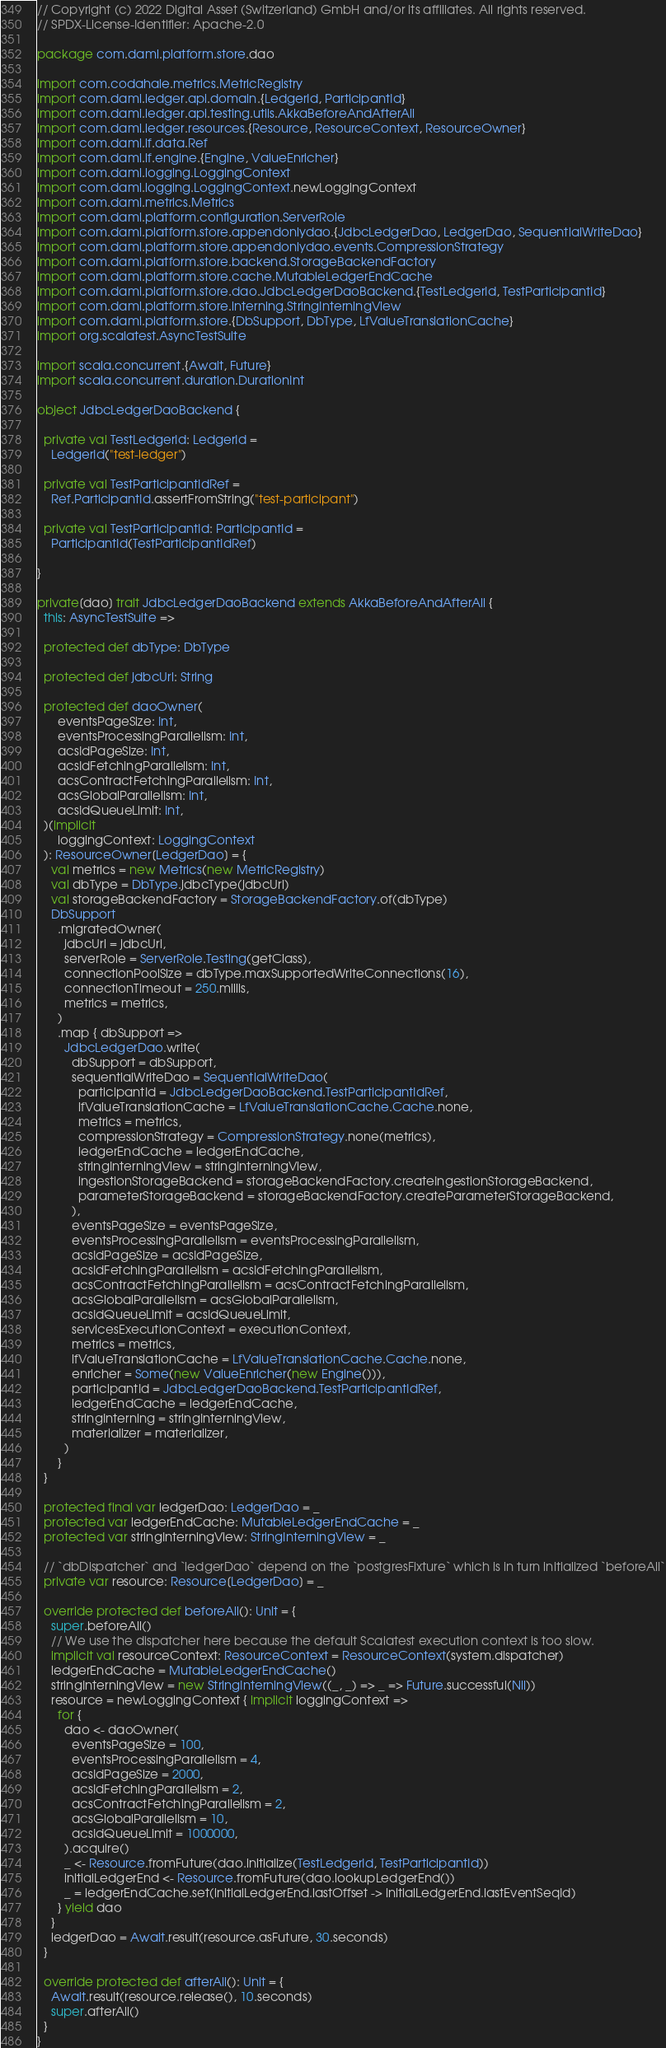Convert code to text. <code><loc_0><loc_0><loc_500><loc_500><_Scala_>// Copyright (c) 2022 Digital Asset (Switzerland) GmbH and/or its affiliates. All rights reserved.
// SPDX-License-Identifier: Apache-2.0

package com.daml.platform.store.dao

import com.codahale.metrics.MetricRegistry
import com.daml.ledger.api.domain.{LedgerId, ParticipantId}
import com.daml.ledger.api.testing.utils.AkkaBeforeAndAfterAll
import com.daml.ledger.resources.{Resource, ResourceContext, ResourceOwner}
import com.daml.lf.data.Ref
import com.daml.lf.engine.{Engine, ValueEnricher}
import com.daml.logging.LoggingContext
import com.daml.logging.LoggingContext.newLoggingContext
import com.daml.metrics.Metrics
import com.daml.platform.configuration.ServerRole
import com.daml.platform.store.appendonlydao.{JdbcLedgerDao, LedgerDao, SequentialWriteDao}
import com.daml.platform.store.appendonlydao.events.CompressionStrategy
import com.daml.platform.store.backend.StorageBackendFactory
import com.daml.platform.store.cache.MutableLedgerEndCache
import com.daml.platform.store.dao.JdbcLedgerDaoBackend.{TestLedgerId, TestParticipantId}
import com.daml.platform.store.interning.StringInterningView
import com.daml.platform.store.{DbSupport, DbType, LfValueTranslationCache}
import org.scalatest.AsyncTestSuite

import scala.concurrent.{Await, Future}
import scala.concurrent.duration.DurationInt

object JdbcLedgerDaoBackend {

  private val TestLedgerId: LedgerId =
    LedgerId("test-ledger")

  private val TestParticipantIdRef =
    Ref.ParticipantId.assertFromString("test-participant")

  private val TestParticipantId: ParticipantId =
    ParticipantId(TestParticipantIdRef)

}

private[dao] trait JdbcLedgerDaoBackend extends AkkaBeforeAndAfterAll {
  this: AsyncTestSuite =>

  protected def dbType: DbType

  protected def jdbcUrl: String

  protected def daoOwner(
      eventsPageSize: Int,
      eventsProcessingParallelism: Int,
      acsIdPageSize: Int,
      acsIdFetchingParallelism: Int,
      acsContractFetchingParallelism: Int,
      acsGlobalParallelism: Int,
      acsIdQueueLimit: Int,
  )(implicit
      loggingContext: LoggingContext
  ): ResourceOwner[LedgerDao] = {
    val metrics = new Metrics(new MetricRegistry)
    val dbType = DbType.jdbcType(jdbcUrl)
    val storageBackendFactory = StorageBackendFactory.of(dbType)
    DbSupport
      .migratedOwner(
        jdbcUrl = jdbcUrl,
        serverRole = ServerRole.Testing(getClass),
        connectionPoolSize = dbType.maxSupportedWriteConnections(16),
        connectionTimeout = 250.millis,
        metrics = metrics,
      )
      .map { dbSupport =>
        JdbcLedgerDao.write(
          dbSupport = dbSupport,
          sequentialWriteDao = SequentialWriteDao(
            participantId = JdbcLedgerDaoBackend.TestParticipantIdRef,
            lfValueTranslationCache = LfValueTranslationCache.Cache.none,
            metrics = metrics,
            compressionStrategy = CompressionStrategy.none(metrics),
            ledgerEndCache = ledgerEndCache,
            stringInterningView = stringInterningView,
            ingestionStorageBackend = storageBackendFactory.createIngestionStorageBackend,
            parameterStorageBackend = storageBackendFactory.createParameterStorageBackend,
          ),
          eventsPageSize = eventsPageSize,
          eventsProcessingParallelism = eventsProcessingParallelism,
          acsIdPageSize = acsIdPageSize,
          acsIdFetchingParallelism = acsIdFetchingParallelism,
          acsContractFetchingParallelism = acsContractFetchingParallelism,
          acsGlobalParallelism = acsGlobalParallelism,
          acsIdQueueLimit = acsIdQueueLimit,
          servicesExecutionContext = executionContext,
          metrics = metrics,
          lfValueTranslationCache = LfValueTranslationCache.Cache.none,
          enricher = Some(new ValueEnricher(new Engine())),
          participantId = JdbcLedgerDaoBackend.TestParticipantIdRef,
          ledgerEndCache = ledgerEndCache,
          stringInterning = stringInterningView,
          materializer = materializer,
        )
      }
  }

  protected final var ledgerDao: LedgerDao = _
  protected var ledgerEndCache: MutableLedgerEndCache = _
  protected var stringInterningView: StringInterningView = _

  // `dbDispatcher` and `ledgerDao` depend on the `postgresFixture` which is in turn initialized `beforeAll`
  private var resource: Resource[LedgerDao] = _

  override protected def beforeAll(): Unit = {
    super.beforeAll()
    // We use the dispatcher here because the default Scalatest execution context is too slow.
    implicit val resourceContext: ResourceContext = ResourceContext(system.dispatcher)
    ledgerEndCache = MutableLedgerEndCache()
    stringInterningView = new StringInterningView((_, _) => _ => Future.successful(Nil))
    resource = newLoggingContext { implicit loggingContext =>
      for {
        dao <- daoOwner(
          eventsPageSize = 100,
          eventsProcessingParallelism = 4,
          acsIdPageSize = 2000,
          acsIdFetchingParallelism = 2,
          acsContractFetchingParallelism = 2,
          acsGlobalParallelism = 10,
          acsIdQueueLimit = 1000000,
        ).acquire()
        _ <- Resource.fromFuture(dao.initialize(TestLedgerId, TestParticipantId))
        initialLedgerEnd <- Resource.fromFuture(dao.lookupLedgerEnd())
        _ = ledgerEndCache.set(initialLedgerEnd.lastOffset -> initialLedgerEnd.lastEventSeqId)
      } yield dao
    }
    ledgerDao = Await.result(resource.asFuture, 30.seconds)
  }

  override protected def afterAll(): Unit = {
    Await.result(resource.release(), 10.seconds)
    super.afterAll()
  }
}
</code> 